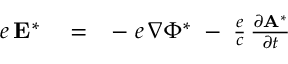Convert formula to latex. <formula><loc_0><loc_0><loc_500><loc_500>\begin{array} { r l r } { e \, { E } ^ { * } } & = } & { - \, e \, \nabla \Phi ^ { * } \, - \, \frac { e } { c } \, \frac { \partial { A } ^ { * } } { \partial t } } \end{array}</formula> 